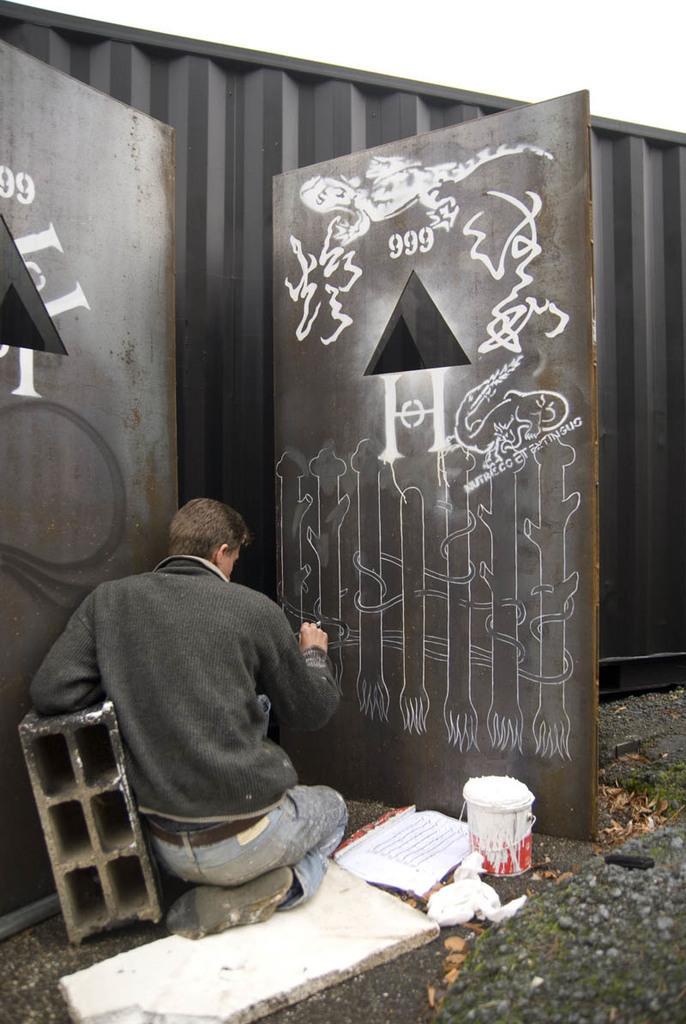Could you give a brief overview of what you see in this image? In this image we can see a person sitting on the floor and painting on the door. In the background there are paint bucket, wooden boards and shredded leaves. 